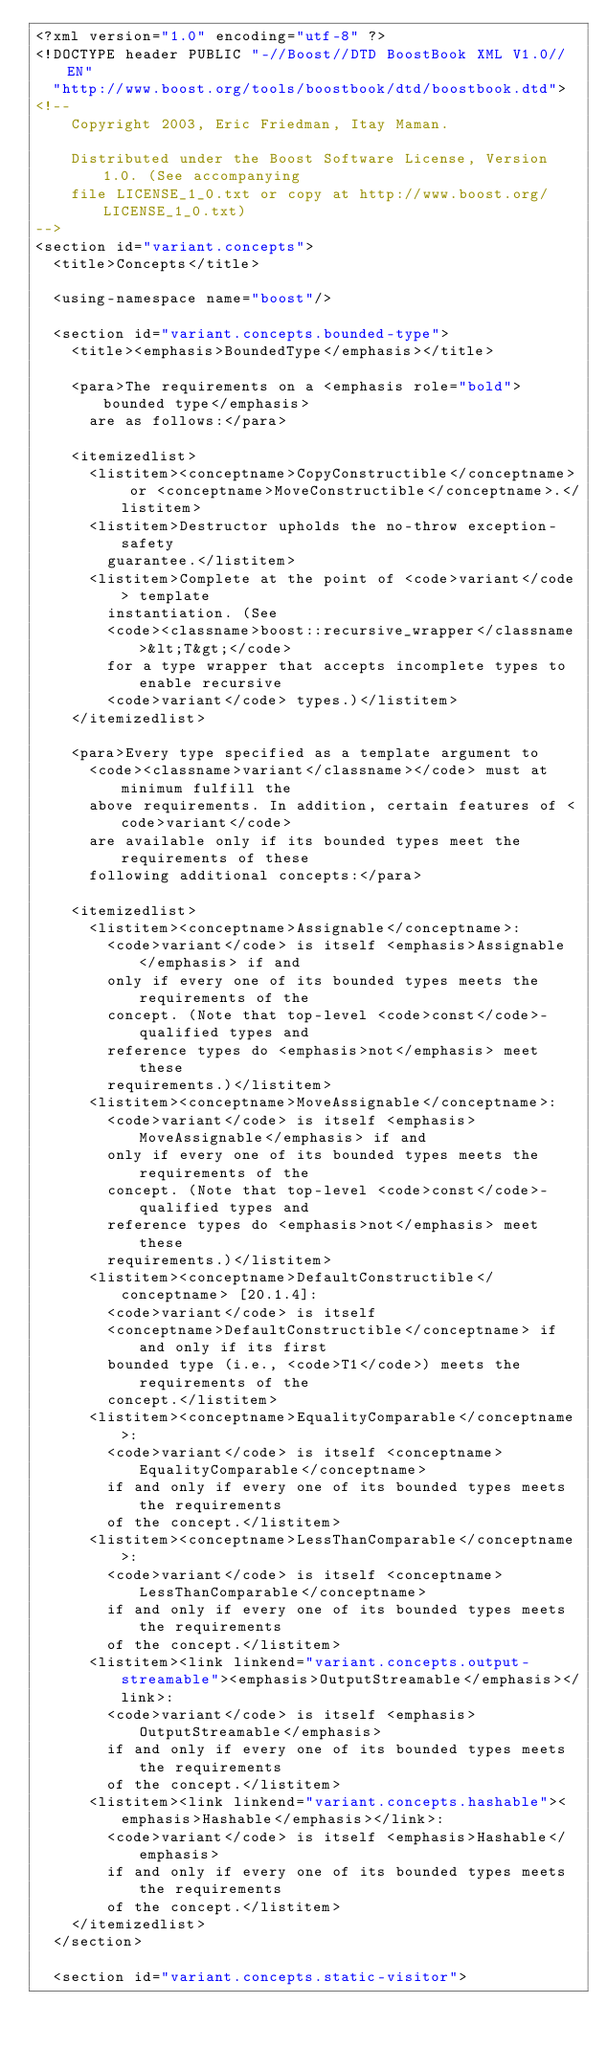Convert code to text. <code><loc_0><loc_0><loc_500><loc_500><_XML_><?xml version="1.0" encoding="utf-8" ?>
<!DOCTYPE header PUBLIC "-//Boost//DTD BoostBook XML V1.0//EN"
  "http://www.boost.org/tools/boostbook/dtd/boostbook.dtd">
<!--
    Copyright 2003, Eric Friedman, Itay Maman.

    Distributed under the Boost Software License, Version 1.0. (See accompanying
    file LICENSE_1_0.txt or copy at http://www.boost.org/LICENSE_1_0.txt)
-->
<section id="variant.concepts">
  <title>Concepts</title>

  <using-namespace name="boost"/>

  <section id="variant.concepts.bounded-type">
    <title><emphasis>BoundedType</emphasis></title>

    <para>The requirements on a <emphasis role="bold">bounded type</emphasis>
      are as follows:</para>

    <itemizedlist>
      <listitem><conceptname>CopyConstructible</conceptname> or <conceptname>MoveConstructible</conceptname>.</listitem>
      <listitem>Destructor upholds the no-throw exception-safety
        guarantee.</listitem>
      <listitem>Complete at the point of <code>variant</code> template
        instantiation. (See
        <code><classname>boost::recursive_wrapper</classname>&lt;T&gt;</code>
        for a type wrapper that accepts incomplete types to enable recursive
        <code>variant</code> types.)</listitem>
    </itemizedlist>

    <para>Every type specified as a template argument to
      <code><classname>variant</classname></code> must at minimum fulfill the
      above requirements. In addition, certain features of <code>variant</code>
      are available only if its bounded types meet the requirements of these
      following additional concepts:</para>

    <itemizedlist>
      <listitem><conceptname>Assignable</conceptname>:
        <code>variant</code> is itself <emphasis>Assignable</emphasis> if and
        only if every one of its bounded types meets the requirements of the
        concept. (Note that top-level <code>const</code>-qualified types and
        reference types do <emphasis>not</emphasis> meet these
        requirements.)</listitem>
      <listitem><conceptname>MoveAssignable</conceptname>:
        <code>variant</code> is itself <emphasis>MoveAssignable</emphasis> if and
        only if every one of its bounded types meets the requirements of the
        concept. (Note that top-level <code>const</code>-qualified types and
        reference types do <emphasis>not</emphasis> meet these
        requirements.)</listitem>
      <listitem><conceptname>DefaultConstructible</conceptname> [20.1.4]:
        <code>variant</code> is itself
        <conceptname>DefaultConstructible</conceptname> if and only if its first
        bounded type (i.e., <code>T1</code>) meets the requirements of the
        concept.</listitem>
      <listitem><conceptname>EqualityComparable</conceptname>:
        <code>variant</code> is itself <conceptname>EqualityComparable</conceptname>
        if and only if every one of its bounded types meets the requirements
        of the concept.</listitem>
      <listitem><conceptname>LessThanComparable</conceptname>:
        <code>variant</code> is itself <conceptname>LessThanComparable</conceptname>
        if and only if every one of its bounded types meets the requirements
        of the concept.</listitem>
      <listitem><link linkend="variant.concepts.output-streamable"><emphasis>OutputStreamable</emphasis></link>:
        <code>variant</code> is itself <emphasis>OutputStreamable</emphasis>
        if and only if every one of its bounded types meets the requirements
        of the concept.</listitem>
      <listitem><link linkend="variant.concepts.hashable"><emphasis>Hashable</emphasis></link>:
        <code>variant</code> is itself <emphasis>Hashable</emphasis>
        if and only if every one of its bounded types meets the requirements
        of the concept.</listitem>
    </itemizedlist>
  </section>

  <section id="variant.concepts.static-visitor"></code> 